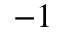Convert formula to latex. <formula><loc_0><loc_0><loc_500><loc_500>^ { - 1 }</formula> 